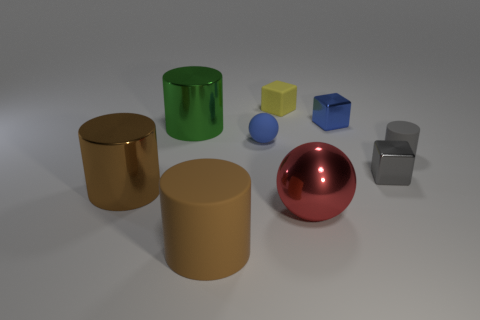Subtract all tiny cylinders. How many cylinders are left? 3 Subtract 1 cylinders. How many cylinders are left? 3 Subtract all cyan cylinders. Subtract all blue spheres. How many cylinders are left? 4 Subtract all cylinders. How many objects are left? 5 Add 1 big red matte balls. How many objects exist? 10 Add 7 tiny cyan blocks. How many tiny cyan blocks exist? 7 Subtract 0 green blocks. How many objects are left? 9 Subtract all gray matte spheres. Subtract all small blue things. How many objects are left? 7 Add 4 small gray matte things. How many small gray matte things are left? 5 